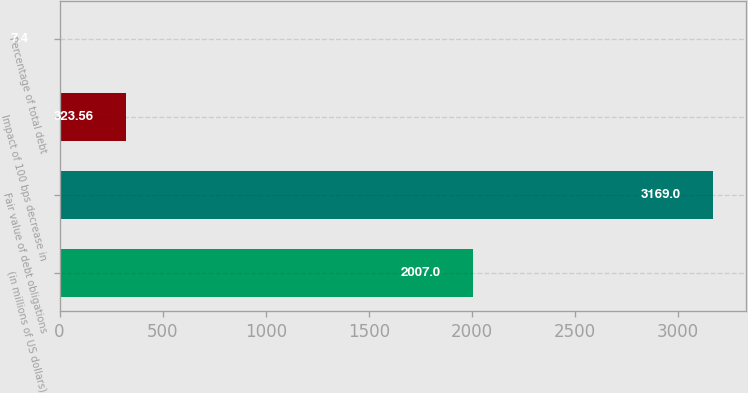Convert chart. <chart><loc_0><loc_0><loc_500><loc_500><bar_chart><fcel>(in millions of US dollars)<fcel>Fair value of debt obligations<fcel>Impact of 100 bps decrease in<fcel>Percentage of total debt<nl><fcel>2007<fcel>3169<fcel>323.56<fcel>7.4<nl></chart> 